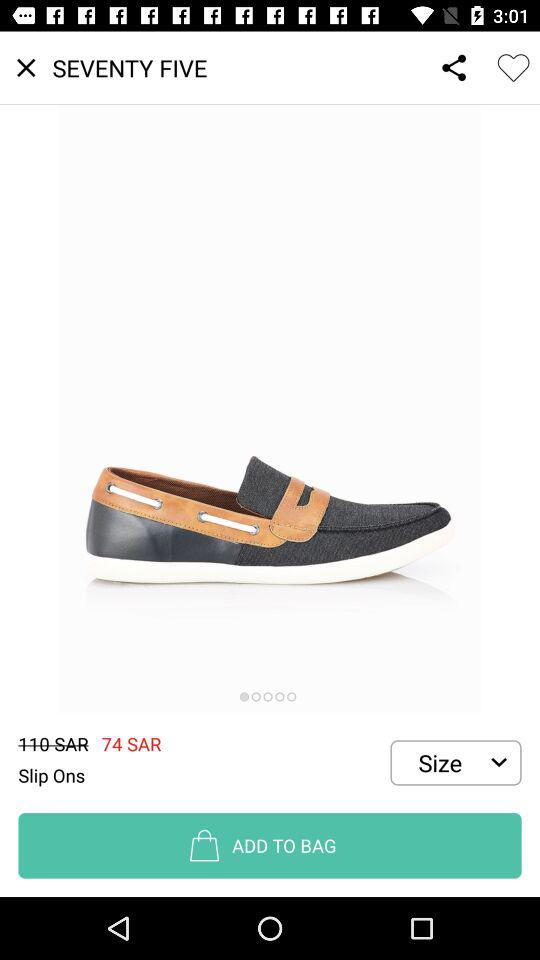How much more is the price of the shoes than the original price?
Answer the question using a single word or phrase. 36 